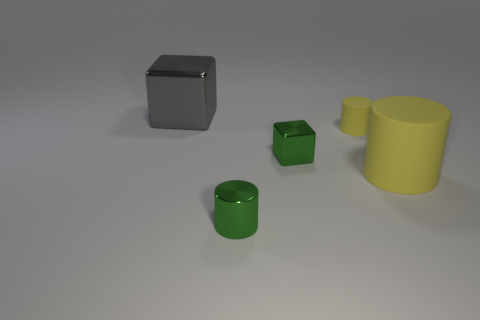What size is the other matte cylinder that is the same color as the big rubber cylinder?
Provide a succinct answer. Small. Is the color of the tiny matte object the same as the big cylinder?
Your answer should be very brief. Yes. What is the cylinder that is both behind the metallic cylinder and left of the large yellow rubber thing made of?
Give a very brief answer. Rubber. There is a object that is the same material as the small yellow cylinder; what size is it?
Offer a very short reply. Large. What material is the big yellow cylinder?
Provide a succinct answer. Rubber. Does the cylinder that is behind the green cube have the same size as the large yellow thing?
Keep it short and to the point. No. What number of things are big yellow metallic objects or small objects?
Keep it short and to the point. 3. The tiny matte object that is the same color as the big matte object is what shape?
Your answer should be compact. Cylinder. There is a cylinder that is on the right side of the small green metal cylinder and in front of the small matte thing; what size is it?
Give a very brief answer. Large. What number of green cylinders are there?
Your answer should be compact. 1. 